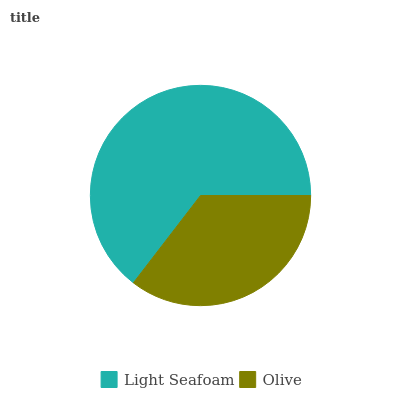Is Olive the minimum?
Answer yes or no. Yes. Is Light Seafoam the maximum?
Answer yes or no. Yes. Is Olive the maximum?
Answer yes or no. No. Is Light Seafoam greater than Olive?
Answer yes or no. Yes. Is Olive less than Light Seafoam?
Answer yes or no. Yes. Is Olive greater than Light Seafoam?
Answer yes or no. No. Is Light Seafoam less than Olive?
Answer yes or no. No. Is Light Seafoam the high median?
Answer yes or no. Yes. Is Olive the low median?
Answer yes or no. Yes. Is Olive the high median?
Answer yes or no. No. Is Light Seafoam the low median?
Answer yes or no. No. 